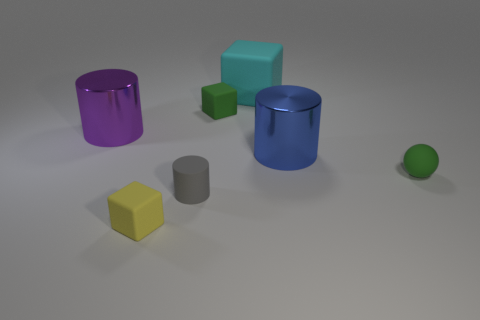Add 2 large blue shiny cylinders. How many objects exist? 9 Subtract all spheres. How many objects are left? 6 Subtract all big metallic objects. Subtract all small gray rubber things. How many objects are left? 4 Add 7 green rubber balls. How many green rubber balls are left? 8 Add 5 green matte cubes. How many green matte cubes exist? 6 Subtract 0 brown blocks. How many objects are left? 7 